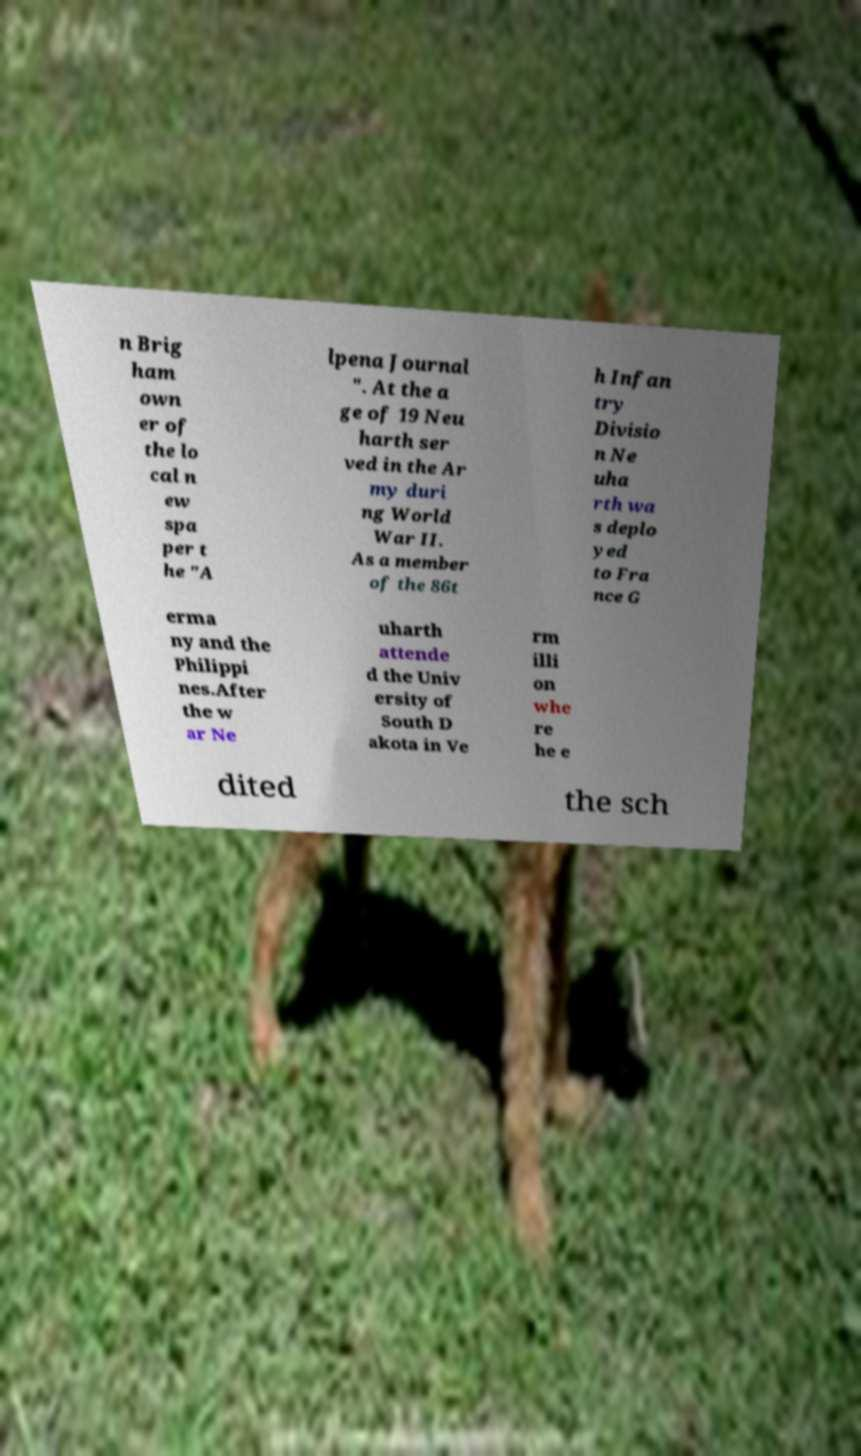Please read and relay the text visible in this image. What does it say? n Brig ham own er of the lo cal n ew spa per t he "A lpena Journal ". At the a ge of 19 Neu harth ser ved in the Ar my duri ng World War II. As a member of the 86t h Infan try Divisio n Ne uha rth wa s deplo yed to Fra nce G erma ny and the Philippi nes.After the w ar Ne uharth attende d the Univ ersity of South D akota in Ve rm illi on whe re he e dited the sch 